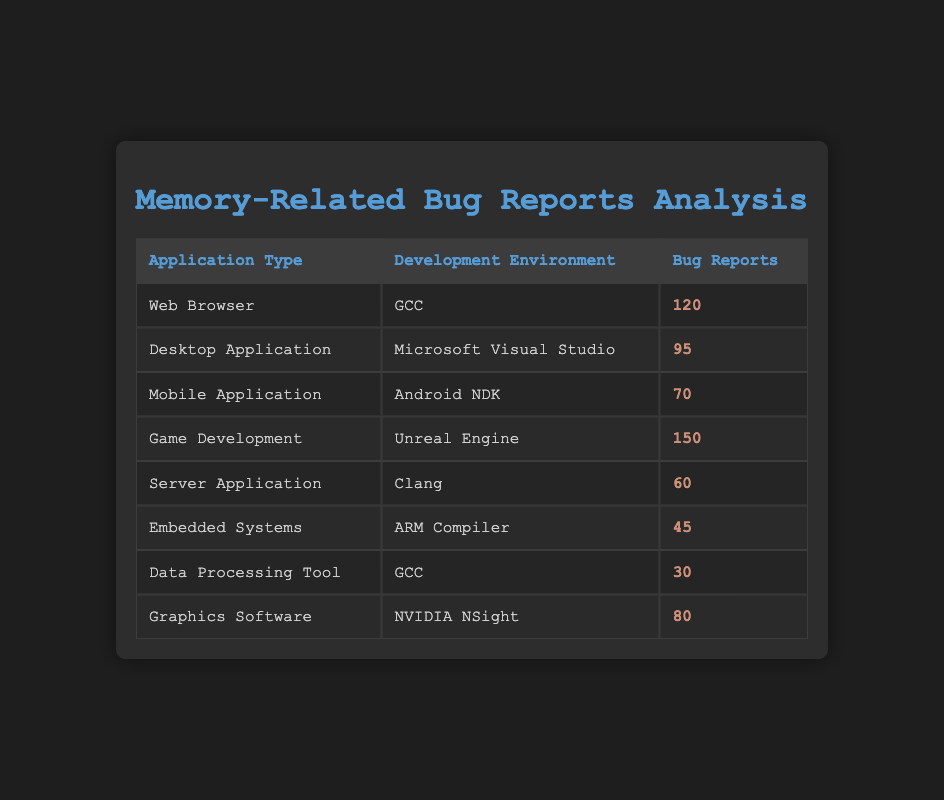What is the highest number of bug reports, and which application type and development environment do they correspond to? The table shows that the highest number of bug reports is 150. This value corresponds to the "Game Development" application type and the "Unreal Engine" development environment.
Answer: 150, Game Development, Unreal Engine How many bug reports are associated with Desktop Applications and Mobile Applications combined? The number of bug reports for Desktop Applications is 95, and for Mobile Applications, it's 70. Summing these gives 95 + 70 = 165.
Answer: 165 Is it true that Server Applications have more bug reports than Embedded Systems? The table shows that Server Applications have 60 bug reports, while Embedded Systems have 45. Since 60 is greater than 45, the statement is true.
Answer: Yes What is the total number of bug reports for applications developed with GCC? There are two application types developed with GCC: "Web Browser" with 120 bug reports and "Data Processing Tool" with 30 bug reports. Adding these gives 120 + 30 = 150.
Answer: 150 Which development environment has the lowest number of memory-related bug reports? By comparing all the bug reports listed by each development environment, ARM Compiler has the lowest count of 45 bug reports related to Embedded Systems.
Answer: ARM Compiler Is there a development environment that does not have any mobile application associated with it? Checking the entries, we see "Android NDK" is listed as the development environment for Mobile Applications, while other development environments like GCC, Microsoft Visual Studio, etc., do not have mobile applications. Thus, yes, there are development environments without any mobile application associated.
Answer: Yes What is the average number of bug reports for applications categorized under Game Development and Graphics Software? From the table, Game Development has 150 bug reports, and Graphics Software has 80. The average is calculated by first summing these values, 150 + 80 = 230, and then dividing by 2 (the number of categories), giving 230 / 2 = 115.
Answer: 115 Which application type has the most bug reports when developed in Microsoft Visual Studio? Only the "Desktop Application" is listed under Microsoft Visual Studio, which has 95 bug reports. Therefore, this application type has the most bug reports in that environment.
Answer: Desktop Application How many more bug reports are there in the Web Browser category than in the Graphics Software category? The Web Browser category has 120 bug reports, while the Graphics Software category has 80. The difference is 120 - 80 = 40.
Answer: 40 